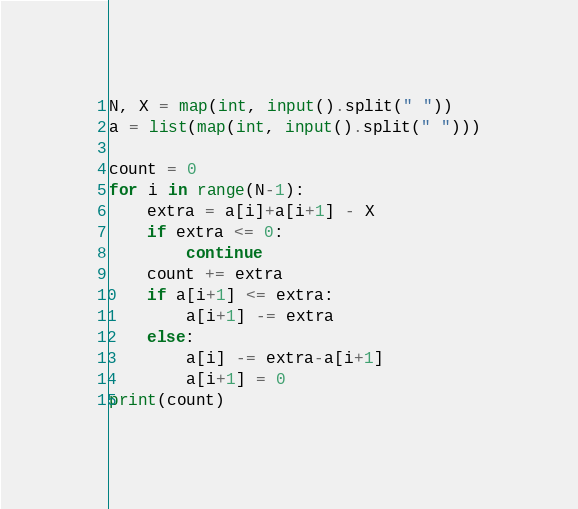Convert code to text. <code><loc_0><loc_0><loc_500><loc_500><_Python_>N, X = map(int, input().split(" "))
a = list(map(int, input().split(" ")))

count = 0
for i in range(N-1):
    extra = a[i]+a[i+1] - X
    if extra <= 0:
        continue
    count += extra
    if a[i+1] <= extra:
        a[i+1] -= extra
    else:
        a[i] -= extra-a[i+1]
        a[i+1] = 0
print(count)
</code> 